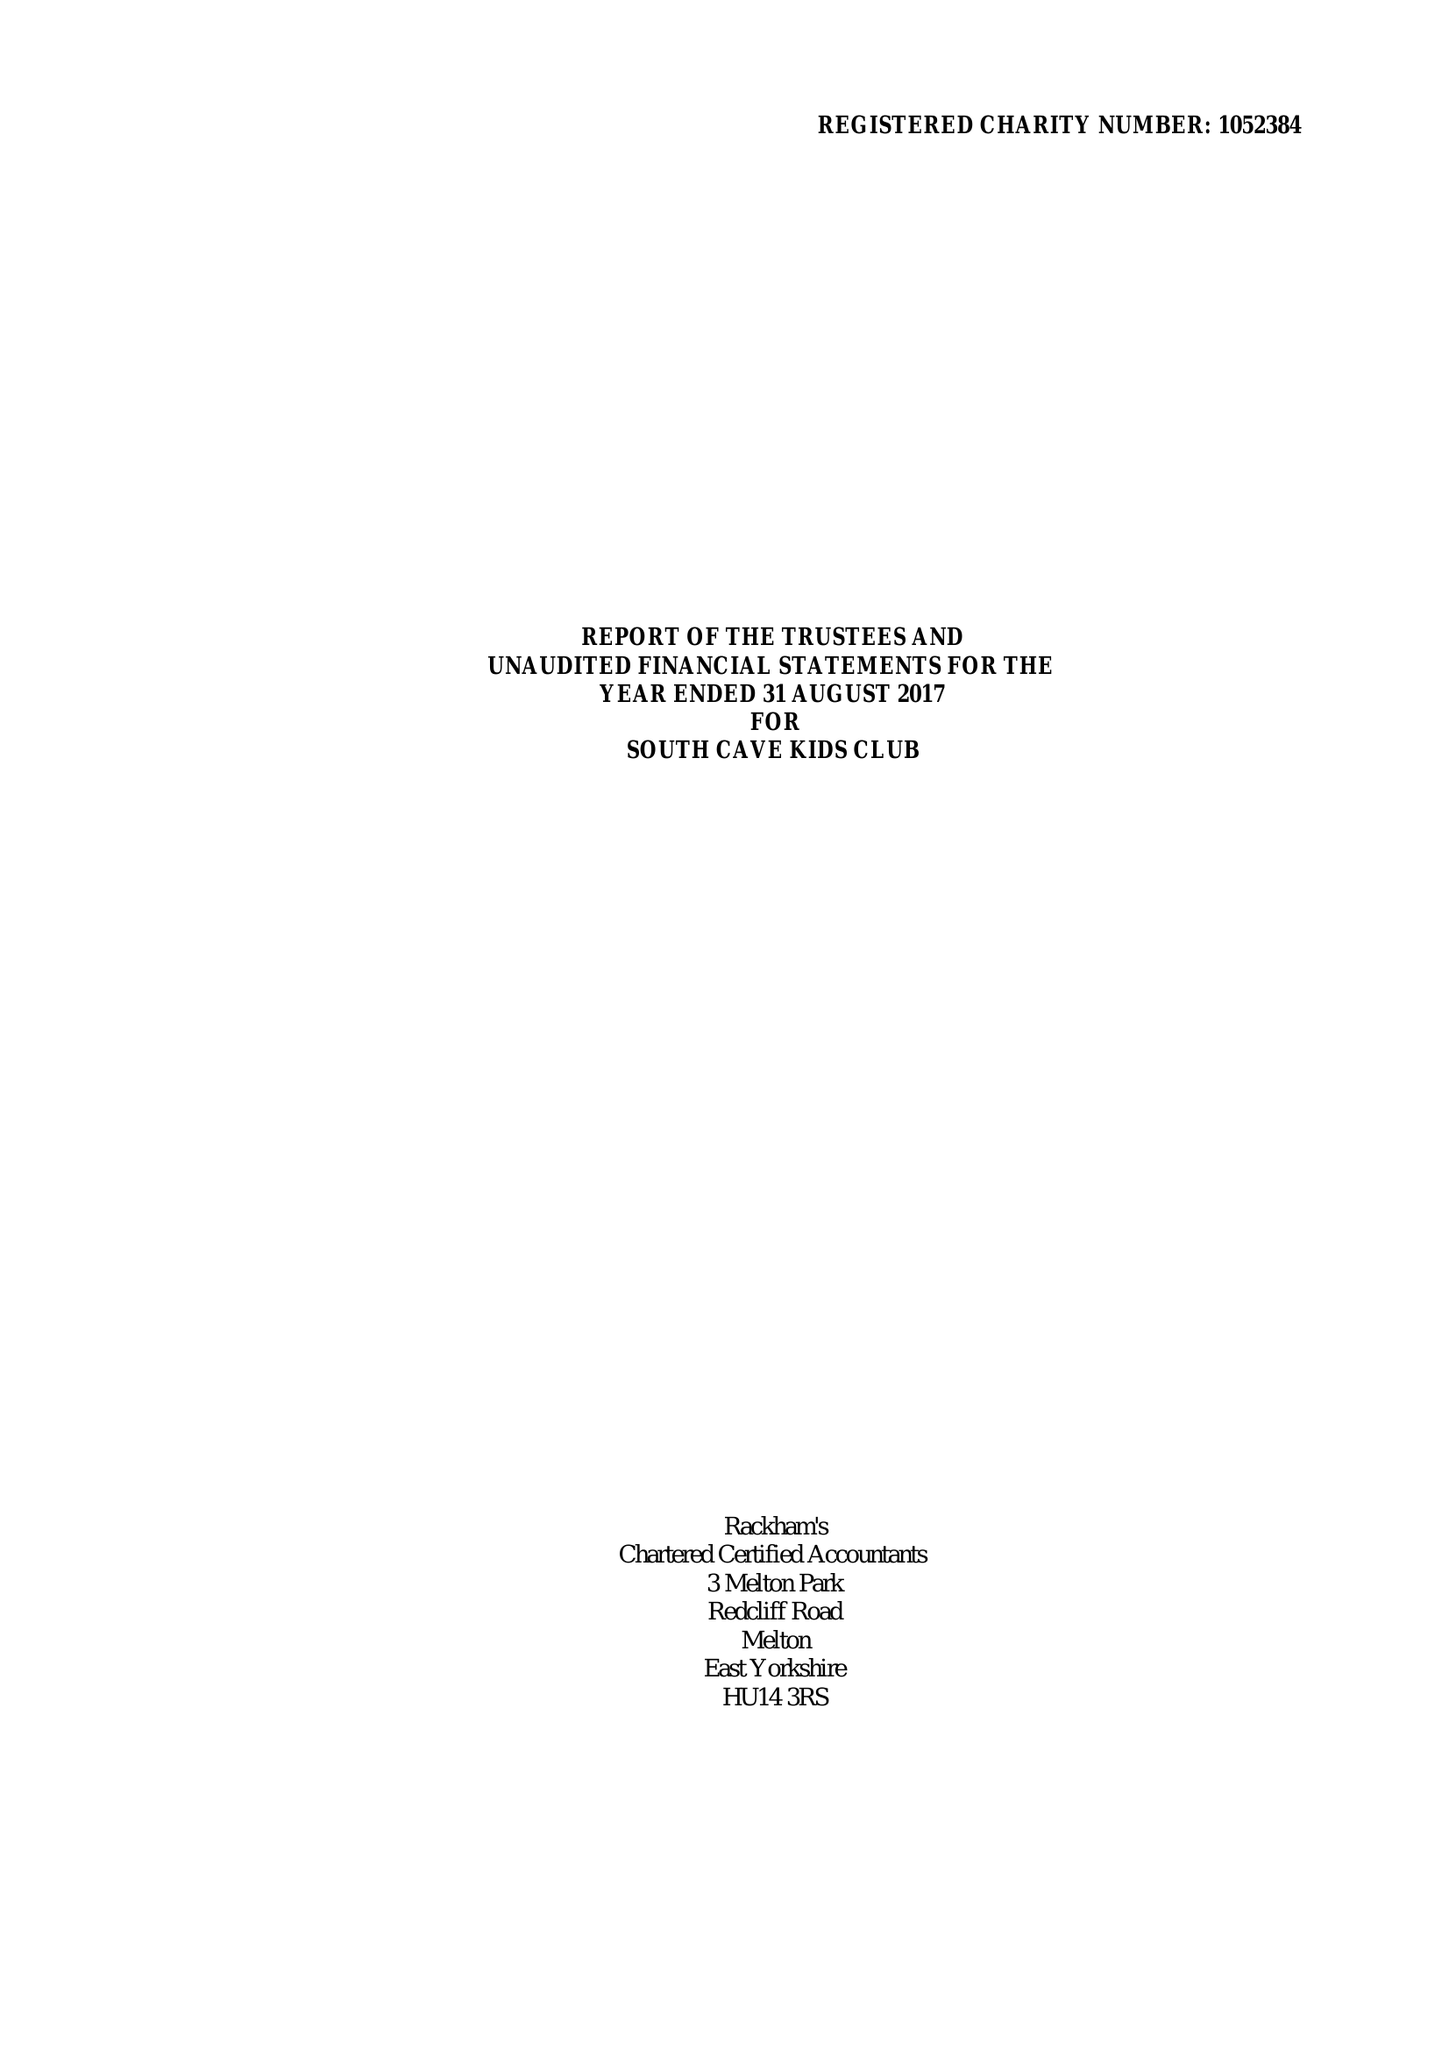What is the value for the address__post_town?
Answer the question using a single word or phrase. BROUGH 